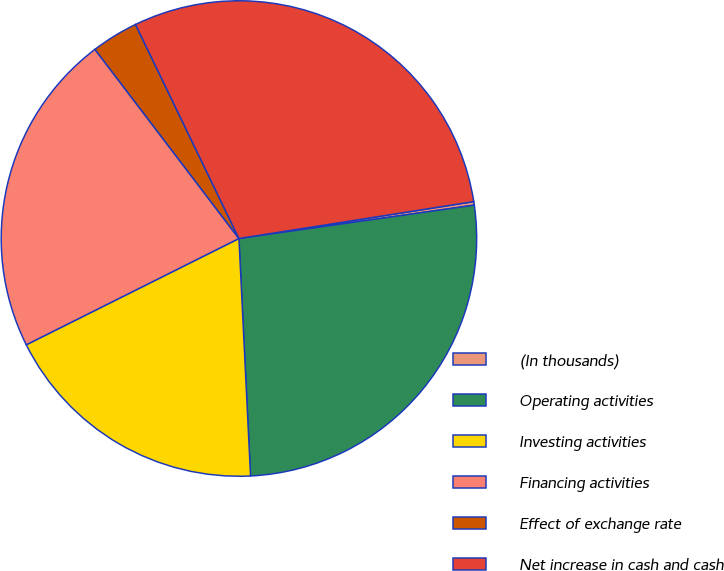Convert chart. <chart><loc_0><loc_0><loc_500><loc_500><pie_chart><fcel>(In thousands)<fcel>Operating activities<fcel>Investing activities<fcel>Financing activities<fcel>Effect of exchange rate<fcel>Net increase in cash and cash<nl><fcel>0.24%<fcel>26.46%<fcel>18.4%<fcel>22.02%<fcel>3.19%<fcel>29.68%<nl></chart> 